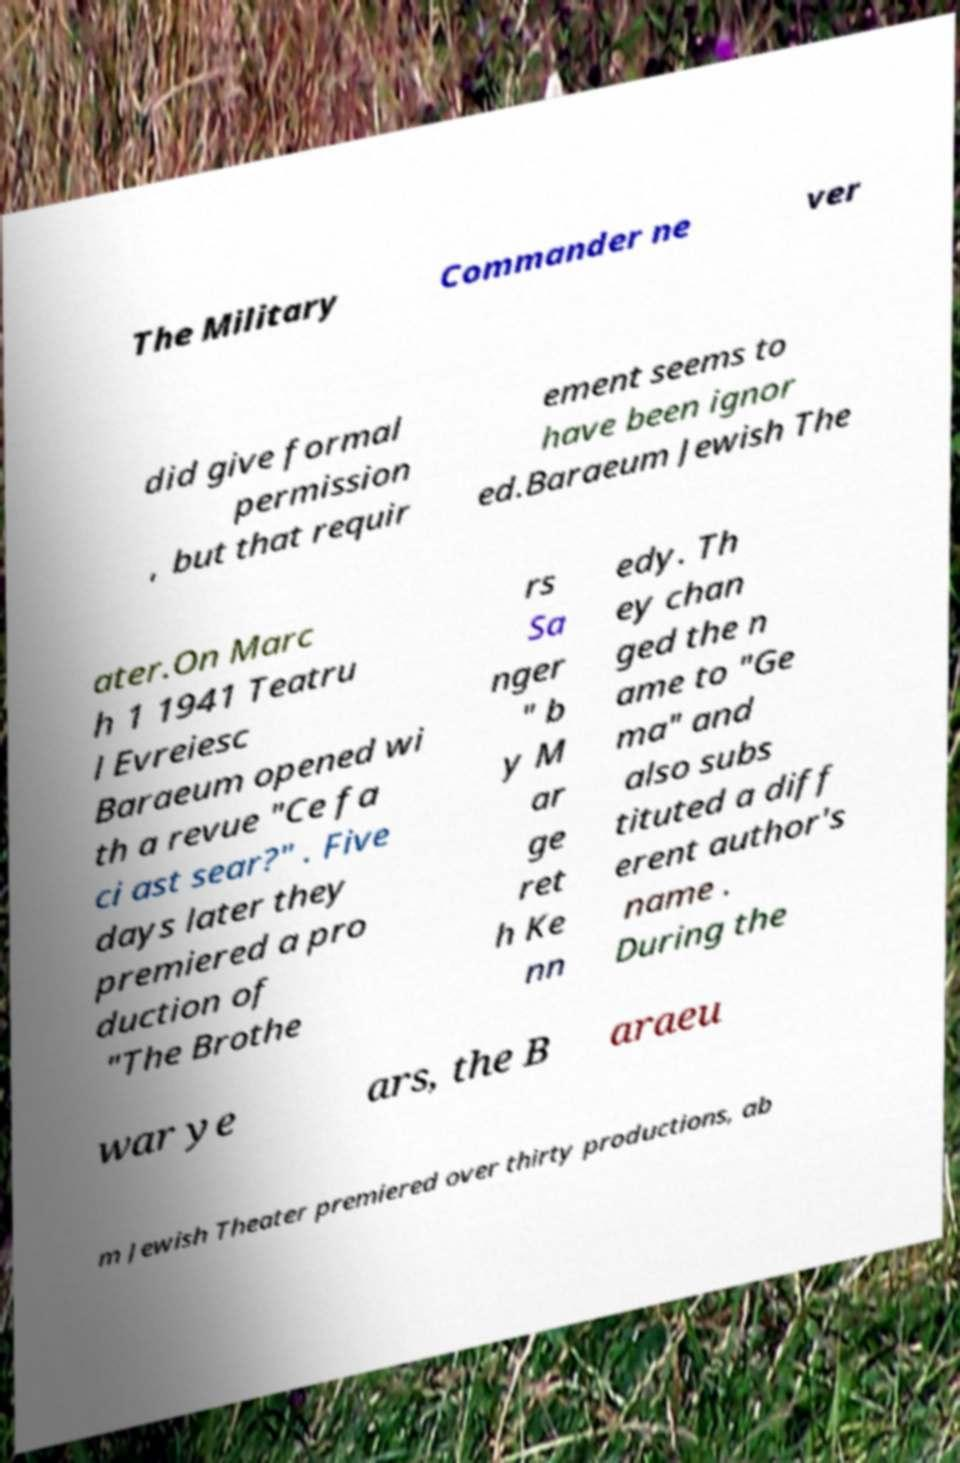Please read and relay the text visible in this image. What does it say? The Military Commander ne ver did give formal permission , but that requir ement seems to have been ignor ed.Baraeum Jewish The ater.On Marc h 1 1941 Teatru l Evreiesc Baraeum opened wi th a revue "Ce fa ci ast sear?" . Five days later they premiered a pro duction of "The Brothe rs Sa nger " b y M ar ge ret h Ke nn edy. Th ey chan ged the n ame to "Ge ma" and also subs tituted a diff erent author's name . During the war ye ars, the B araeu m Jewish Theater premiered over thirty productions, ab 